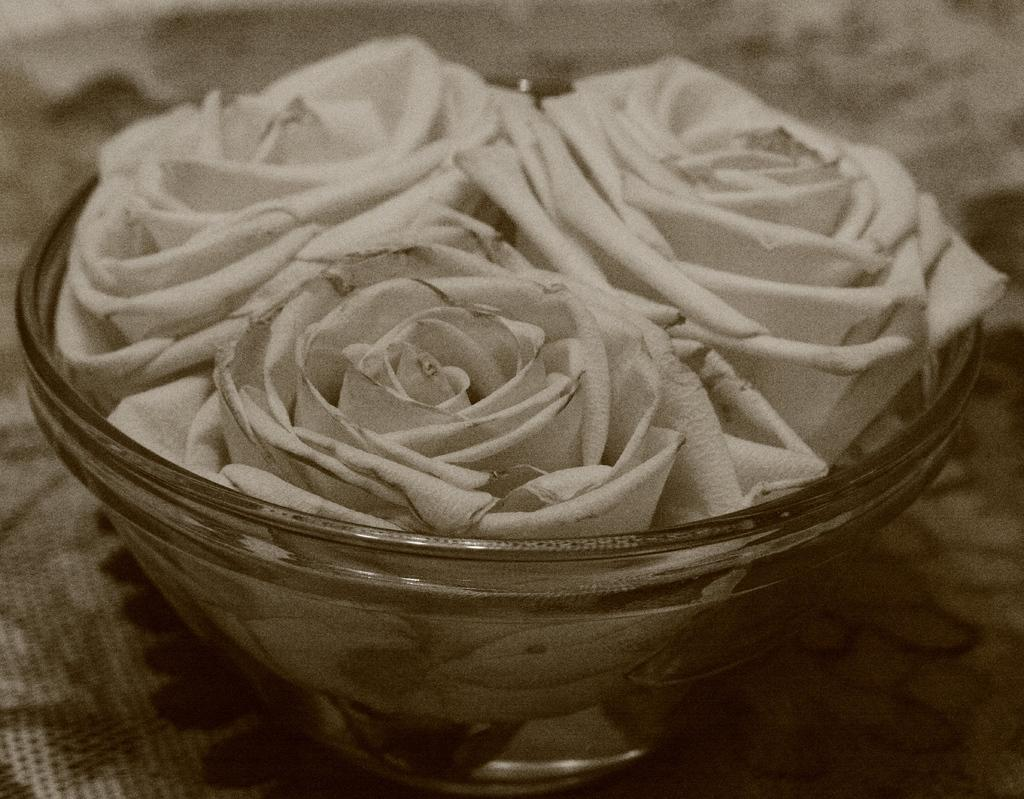What type of flowers are in the image? There are white roses in the image. How are the white roses arranged or displayed? The white roses are in a glass bowl. Where is the glass bowl with the white roses located? The glass bowl with the white roses is kept on a table. How much did the daughter spend on the flowers at the market? There is no mention of a daughter or a market in the image, so we cannot determine how much was spent on the flowers. 